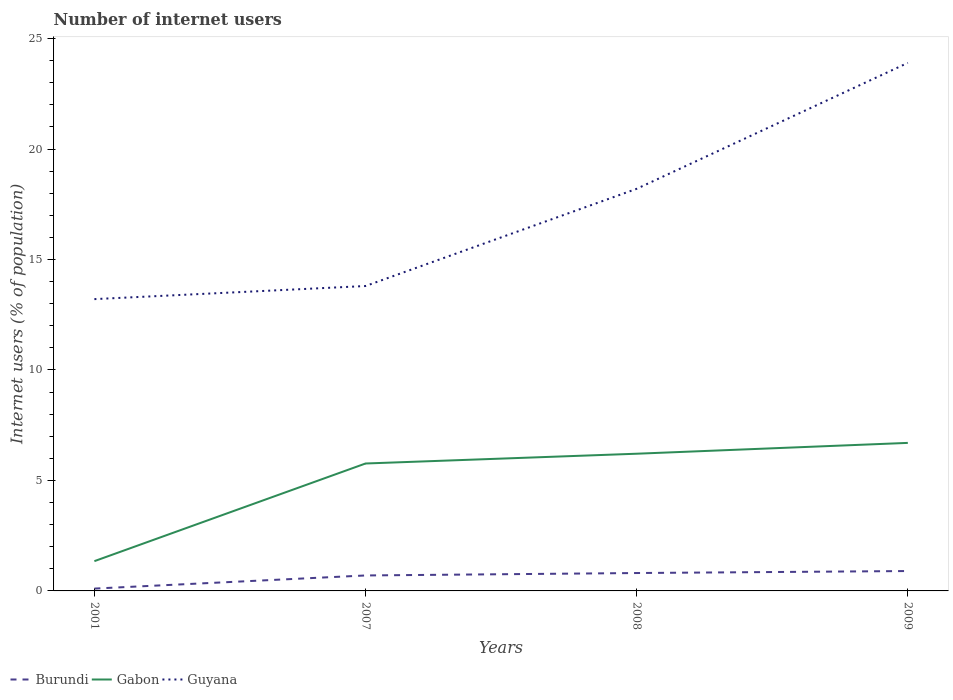Is the number of lines equal to the number of legend labels?
Offer a very short reply. Yes. Across all years, what is the maximum number of internet users in Gabon?
Keep it short and to the point. 1.35. In which year was the number of internet users in Burundi maximum?
Your answer should be compact. 2001. What is the total number of internet users in Guyana in the graph?
Offer a very short reply. -10.69. What is the difference between the highest and the second highest number of internet users in Gabon?
Keep it short and to the point. 5.35. What is the difference between the highest and the lowest number of internet users in Burundi?
Offer a very short reply. 3. How many lines are there?
Provide a short and direct response. 3. What is the difference between two consecutive major ticks on the Y-axis?
Ensure brevity in your answer.  5. Are the values on the major ticks of Y-axis written in scientific E-notation?
Your answer should be very brief. No. Does the graph contain any zero values?
Give a very brief answer. No. Does the graph contain grids?
Keep it short and to the point. No. How are the legend labels stacked?
Provide a succinct answer. Horizontal. What is the title of the graph?
Give a very brief answer. Number of internet users. What is the label or title of the Y-axis?
Provide a short and direct response. Internet users (% of population). What is the Internet users (% of population) of Burundi in 2001?
Provide a succinct answer. 0.11. What is the Internet users (% of population) in Gabon in 2001?
Offer a very short reply. 1.35. What is the Internet users (% of population) of Guyana in 2001?
Your answer should be very brief. 13.21. What is the Internet users (% of population) of Burundi in 2007?
Provide a succinct answer. 0.7. What is the Internet users (% of population) in Gabon in 2007?
Offer a very short reply. 5.77. What is the Internet users (% of population) of Guyana in 2007?
Your answer should be very brief. 13.8. What is the Internet users (% of population) in Burundi in 2008?
Make the answer very short. 0.81. What is the Internet users (% of population) of Gabon in 2008?
Offer a very short reply. 6.21. What is the Internet users (% of population) of Guyana in 2008?
Provide a short and direct response. 18.2. What is the Internet users (% of population) of Gabon in 2009?
Your answer should be very brief. 6.7. What is the Internet users (% of population) of Guyana in 2009?
Your response must be concise. 23.9. Across all years, what is the maximum Internet users (% of population) in Burundi?
Offer a very short reply. 0.9. Across all years, what is the maximum Internet users (% of population) in Gabon?
Your answer should be very brief. 6.7. Across all years, what is the maximum Internet users (% of population) in Guyana?
Keep it short and to the point. 23.9. Across all years, what is the minimum Internet users (% of population) in Burundi?
Give a very brief answer. 0.11. Across all years, what is the minimum Internet users (% of population) in Gabon?
Offer a terse response. 1.35. Across all years, what is the minimum Internet users (% of population) in Guyana?
Provide a succinct answer. 13.21. What is the total Internet users (% of population) of Burundi in the graph?
Provide a succinct answer. 2.52. What is the total Internet users (% of population) of Gabon in the graph?
Make the answer very short. 20.02. What is the total Internet users (% of population) of Guyana in the graph?
Offer a very short reply. 69.11. What is the difference between the Internet users (% of population) of Burundi in 2001 and that in 2007?
Make the answer very short. -0.59. What is the difference between the Internet users (% of population) of Gabon in 2001 and that in 2007?
Keep it short and to the point. -4.42. What is the difference between the Internet users (% of population) of Guyana in 2001 and that in 2007?
Keep it short and to the point. -0.59. What is the difference between the Internet users (% of population) in Burundi in 2001 and that in 2008?
Offer a terse response. -0.7. What is the difference between the Internet users (% of population) of Gabon in 2001 and that in 2008?
Provide a short and direct response. -4.86. What is the difference between the Internet users (% of population) of Guyana in 2001 and that in 2008?
Provide a short and direct response. -4.99. What is the difference between the Internet users (% of population) in Burundi in 2001 and that in 2009?
Provide a succinct answer. -0.79. What is the difference between the Internet users (% of population) in Gabon in 2001 and that in 2009?
Provide a succinct answer. -5.35. What is the difference between the Internet users (% of population) of Guyana in 2001 and that in 2009?
Your answer should be very brief. -10.69. What is the difference between the Internet users (% of population) in Burundi in 2007 and that in 2008?
Give a very brief answer. -0.11. What is the difference between the Internet users (% of population) in Gabon in 2007 and that in 2008?
Provide a short and direct response. -0.44. What is the difference between the Internet users (% of population) in Guyana in 2007 and that in 2008?
Offer a terse response. -4.4. What is the difference between the Internet users (% of population) of Gabon in 2007 and that in 2009?
Provide a short and direct response. -0.93. What is the difference between the Internet users (% of population) of Guyana in 2007 and that in 2009?
Your answer should be very brief. -10.1. What is the difference between the Internet users (% of population) in Burundi in 2008 and that in 2009?
Offer a terse response. -0.09. What is the difference between the Internet users (% of population) of Gabon in 2008 and that in 2009?
Your answer should be compact. -0.49. What is the difference between the Internet users (% of population) in Burundi in 2001 and the Internet users (% of population) in Gabon in 2007?
Offer a terse response. -5.66. What is the difference between the Internet users (% of population) of Burundi in 2001 and the Internet users (% of population) of Guyana in 2007?
Make the answer very short. -13.69. What is the difference between the Internet users (% of population) in Gabon in 2001 and the Internet users (% of population) in Guyana in 2007?
Offer a terse response. -12.45. What is the difference between the Internet users (% of population) of Burundi in 2001 and the Internet users (% of population) of Gabon in 2008?
Your answer should be very brief. -6.1. What is the difference between the Internet users (% of population) of Burundi in 2001 and the Internet users (% of population) of Guyana in 2008?
Provide a short and direct response. -18.09. What is the difference between the Internet users (% of population) of Gabon in 2001 and the Internet users (% of population) of Guyana in 2008?
Your answer should be compact. -16.85. What is the difference between the Internet users (% of population) of Burundi in 2001 and the Internet users (% of population) of Gabon in 2009?
Offer a very short reply. -6.59. What is the difference between the Internet users (% of population) in Burundi in 2001 and the Internet users (% of population) in Guyana in 2009?
Give a very brief answer. -23.79. What is the difference between the Internet users (% of population) of Gabon in 2001 and the Internet users (% of population) of Guyana in 2009?
Your answer should be compact. -22.55. What is the difference between the Internet users (% of population) of Burundi in 2007 and the Internet users (% of population) of Gabon in 2008?
Give a very brief answer. -5.51. What is the difference between the Internet users (% of population) of Burundi in 2007 and the Internet users (% of population) of Guyana in 2008?
Provide a short and direct response. -17.5. What is the difference between the Internet users (% of population) in Gabon in 2007 and the Internet users (% of population) in Guyana in 2008?
Your answer should be compact. -12.43. What is the difference between the Internet users (% of population) in Burundi in 2007 and the Internet users (% of population) in Guyana in 2009?
Give a very brief answer. -23.2. What is the difference between the Internet users (% of population) of Gabon in 2007 and the Internet users (% of population) of Guyana in 2009?
Provide a succinct answer. -18.13. What is the difference between the Internet users (% of population) of Burundi in 2008 and the Internet users (% of population) of Gabon in 2009?
Keep it short and to the point. -5.89. What is the difference between the Internet users (% of population) in Burundi in 2008 and the Internet users (% of population) in Guyana in 2009?
Your answer should be compact. -23.09. What is the difference between the Internet users (% of population) of Gabon in 2008 and the Internet users (% of population) of Guyana in 2009?
Your answer should be compact. -17.69. What is the average Internet users (% of population) of Burundi per year?
Offer a very short reply. 0.63. What is the average Internet users (% of population) in Gabon per year?
Your response must be concise. 5.01. What is the average Internet users (% of population) of Guyana per year?
Your answer should be compact. 17.28. In the year 2001, what is the difference between the Internet users (% of population) in Burundi and Internet users (% of population) in Gabon?
Your answer should be compact. -1.24. In the year 2001, what is the difference between the Internet users (% of population) of Burundi and Internet users (% of population) of Guyana?
Your answer should be compact. -13.1. In the year 2001, what is the difference between the Internet users (% of population) in Gabon and Internet users (% of population) in Guyana?
Offer a terse response. -11.86. In the year 2007, what is the difference between the Internet users (% of population) in Burundi and Internet users (% of population) in Gabon?
Offer a very short reply. -5.07. In the year 2007, what is the difference between the Internet users (% of population) of Burundi and Internet users (% of population) of Guyana?
Keep it short and to the point. -13.1. In the year 2007, what is the difference between the Internet users (% of population) of Gabon and Internet users (% of population) of Guyana?
Offer a very short reply. -8.03. In the year 2008, what is the difference between the Internet users (% of population) of Burundi and Internet users (% of population) of Guyana?
Keep it short and to the point. -17.39. In the year 2008, what is the difference between the Internet users (% of population) in Gabon and Internet users (% of population) in Guyana?
Keep it short and to the point. -11.99. In the year 2009, what is the difference between the Internet users (% of population) of Burundi and Internet users (% of population) of Guyana?
Provide a short and direct response. -23. In the year 2009, what is the difference between the Internet users (% of population) in Gabon and Internet users (% of population) in Guyana?
Your response must be concise. -17.2. What is the ratio of the Internet users (% of population) of Burundi in 2001 to that in 2007?
Provide a short and direct response. 0.15. What is the ratio of the Internet users (% of population) of Gabon in 2001 to that in 2007?
Your answer should be compact. 0.23. What is the ratio of the Internet users (% of population) in Burundi in 2001 to that in 2008?
Make the answer very short. 0.13. What is the ratio of the Internet users (% of population) of Gabon in 2001 to that in 2008?
Provide a succinct answer. 0.22. What is the ratio of the Internet users (% of population) of Guyana in 2001 to that in 2008?
Your response must be concise. 0.73. What is the ratio of the Internet users (% of population) in Burundi in 2001 to that in 2009?
Provide a short and direct response. 0.12. What is the ratio of the Internet users (% of population) of Gabon in 2001 to that in 2009?
Your response must be concise. 0.2. What is the ratio of the Internet users (% of population) in Guyana in 2001 to that in 2009?
Provide a succinct answer. 0.55. What is the ratio of the Internet users (% of population) of Burundi in 2007 to that in 2008?
Keep it short and to the point. 0.86. What is the ratio of the Internet users (% of population) of Gabon in 2007 to that in 2008?
Provide a short and direct response. 0.93. What is the ratio of the Internet users (% of population) of Guyana in 2007 to that in 2008?
Give a very brief answer. 0.76. What is the ratio of the Internet users (% of population) in Burundi in 2007 to that in 2009?
Keep it short and to the point. 0.78. What is the ratio of the Internet users (% of population) in Gabon in 2007 to that in 2009?
Your response must be concise. 0.86. What is the ratio of the Internet users (% of population) of Guyana in 2007 to that in 2009?
Offer a very short reply. 0.58. What is the ratio of the Internet users (% of population) in Gabon in 2008 to that in 2009?
Ensure brevity in your answer.  0.93. What is the ratio of the Internet users (% of population) in Guyana in 2008 to that in 2009?
Provide a succinct answer. 0.76. What is the difference between the highest and the second highest Internet users (% of population) in Burundi?
Offer a very short reply. 0.09. What is the difference between the highest and the second highest Internet users (% of population) in Gabon?
Your response must be concise. 0.49. What is the difference between the highest and the second highest Internet users (% of population) in Guyana?
Ensure brevity in your answer.  5.7. What is the difference between the highest and the lowest Internet users (% of population) of Burundi?
Keep it short and to the point. 0.79. What is the difference between the highest and the lowest Internet users (% of population) of Gabon?
Make the answer very short. 5.35. What is the difference between the highest and the lowest Internet users (% of population) of Guyana?
Your response must be concise. 10.69. 